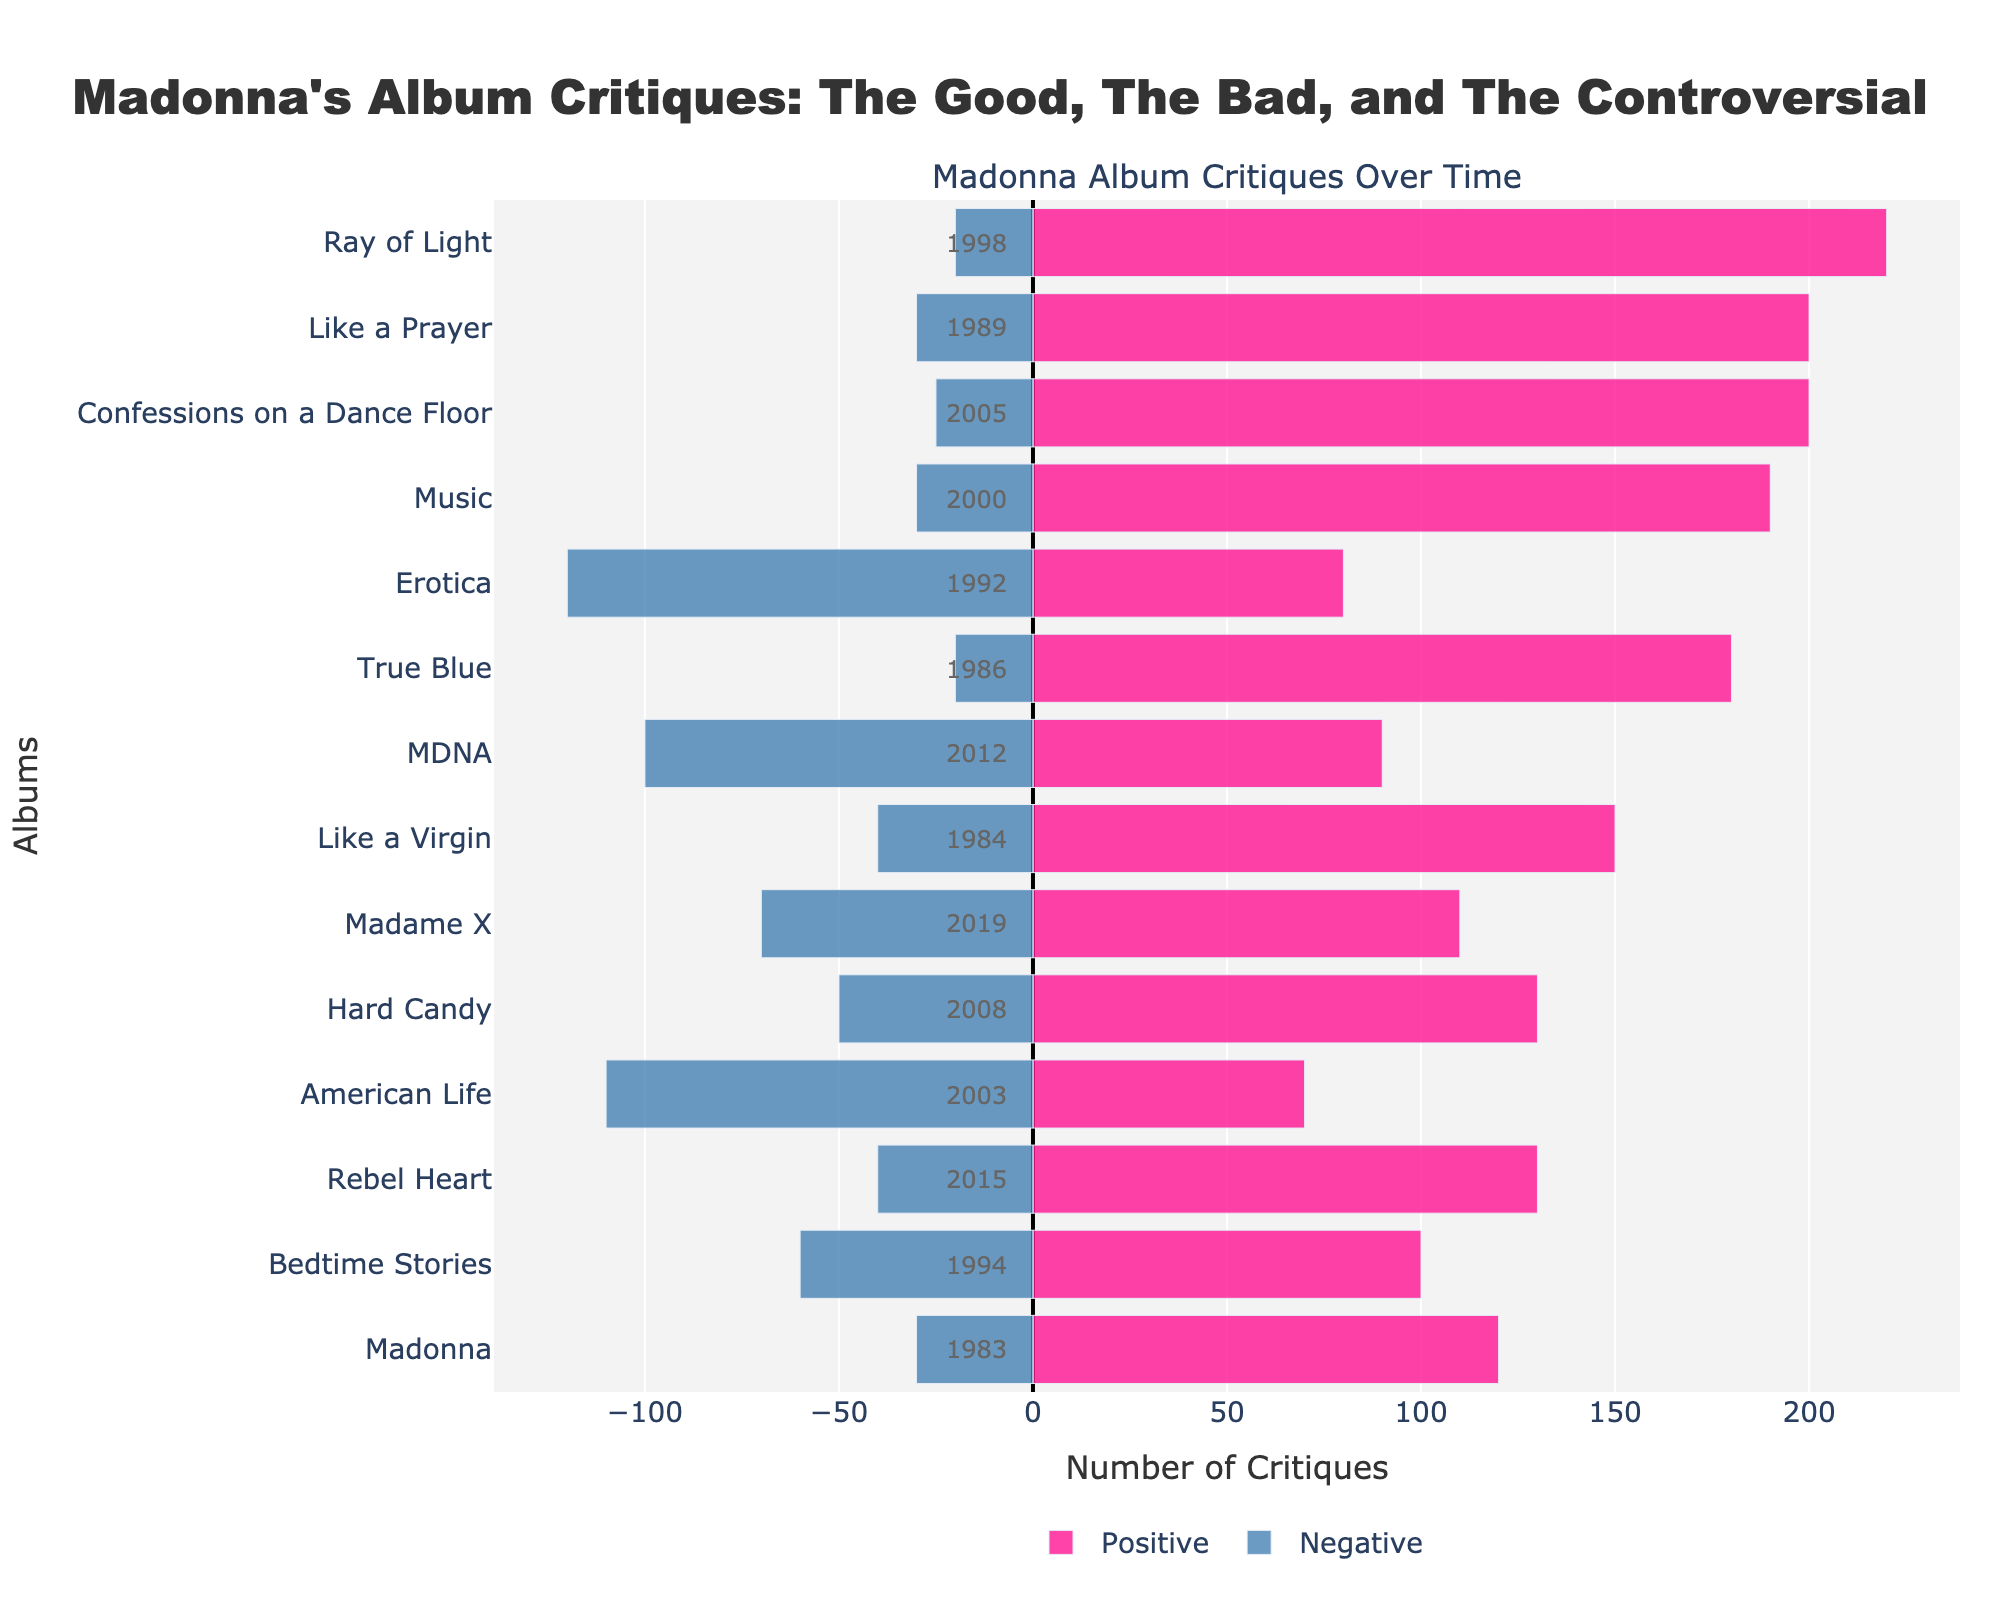Which album received the most positive critiques? The album with the tallest bar on the positive side (pink) represents the most positive critiques. "Ray of Light" has the tallest pink bar.
Answer: Ray of Light Which album had more negative critiques: "Erotica" or "American Life"? Compare the lengths of the negative bars (blue) for "Erotica" and "American Life". "Erotica" has a longer bar compared to "American Life", indicating more negative critiques.
Answer: Erotica What is the total number of critiques for the "Ray of Light" album? Sum the number of positive and negative critiques for "Ray of Light". Positive Critiques = 220, Negative Critiques = 20. Total = 220 + 20 = 240.
Answer: 240 Which album has the highest difference between positive and negative critiques? Calculate the differences between positive and negative critiques for each album and identify the maximum. "Ray of Light" has the highest difference (220 - 20 = 200).
Answer: Ray of Light How many albums have at least 100 negative critiques? Count the albums where the length of the negative bar (blue) is greater than or equal to 100. "Erotica", "American Life", and "MDNA" have at least 100 negative critiques.
Answer: 3 Which albums received exactly 40 negative critiques? Identify the albums where the blue bars have a value of 40. "Like a Virgin" and "Rebel Heart" have 40 negative critiques.
Answer: Like a Virgin, Rebel Heart What is the average number of positive critiques across all albums? Sum the positive critiques for all albums and divide by the number of albums. Total Positive Critiques = 120 + 150 + 180 + 200 + 80 + 100 + 220 + 190 + 70 + 200 + 130 + 90 + 130 + 110 = 1970. Number of Albums = 14. Average = 1970/14 ≈ 140.71.
Answer: 140.71 Compare the total critiques of "Confessions on a Dance Floor" and "Hard Candy". Which album has more? Sum the positive and negative critiques for each album and compare. "Confessions on a Dance Floor": 200 + 25 = 225. "Hard Candy": 130 + 50 = 180. 225 is more than 180.
Answer: Confessions on a Dance Floor What percentage of the critiques for "MDNA" are negative? Divide the number of negative critiques by the total critiques for "MDNA" and multiply by 100. Negative Critiques = 100. Total Critiques = 90 + 100 = 190. Percentage = (100/190) * 100 ≈ 52.63%.
Answer: 52.63% Which album released after 2000 has the fewest positive critiques? Identify the albums released after 2000 and compare their positive critique bars. "American Life" (2003) received the fewest positive critiques with 70.
Answer: American Life 